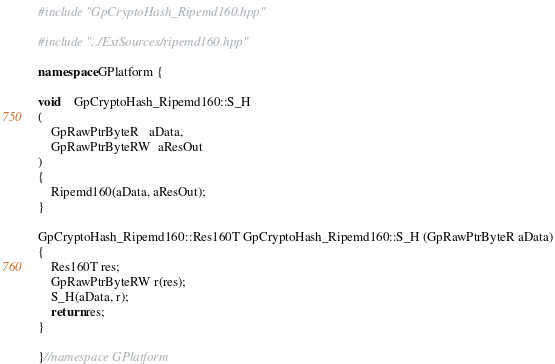<code> <loc_0><loc_0><loc_500><loc_500><_C++_>#include "GpCryptoHash_Ripemd160.hpp"

#include "../ExtSources/ripemd160.hpp"

namespace GPlatform {

void    GpCryptoHash_Ripemd160::S_H
(
    GpRawPtrByteR   aData,
    GpRawPtrByteRW  aResOut
)
{
    Ripemd160(aData, aResOut);
}

GpCryptoHash_Ripemd160::Res160T GpCryptoHash_Ripemd160::S_H (GpRawPtrByteR aData)
{
    Res160T res;
    GpRawPtrByteRW r(res);
    S_H(aData, r);
    return res;
}

}//namespace GPlatform
</code> 